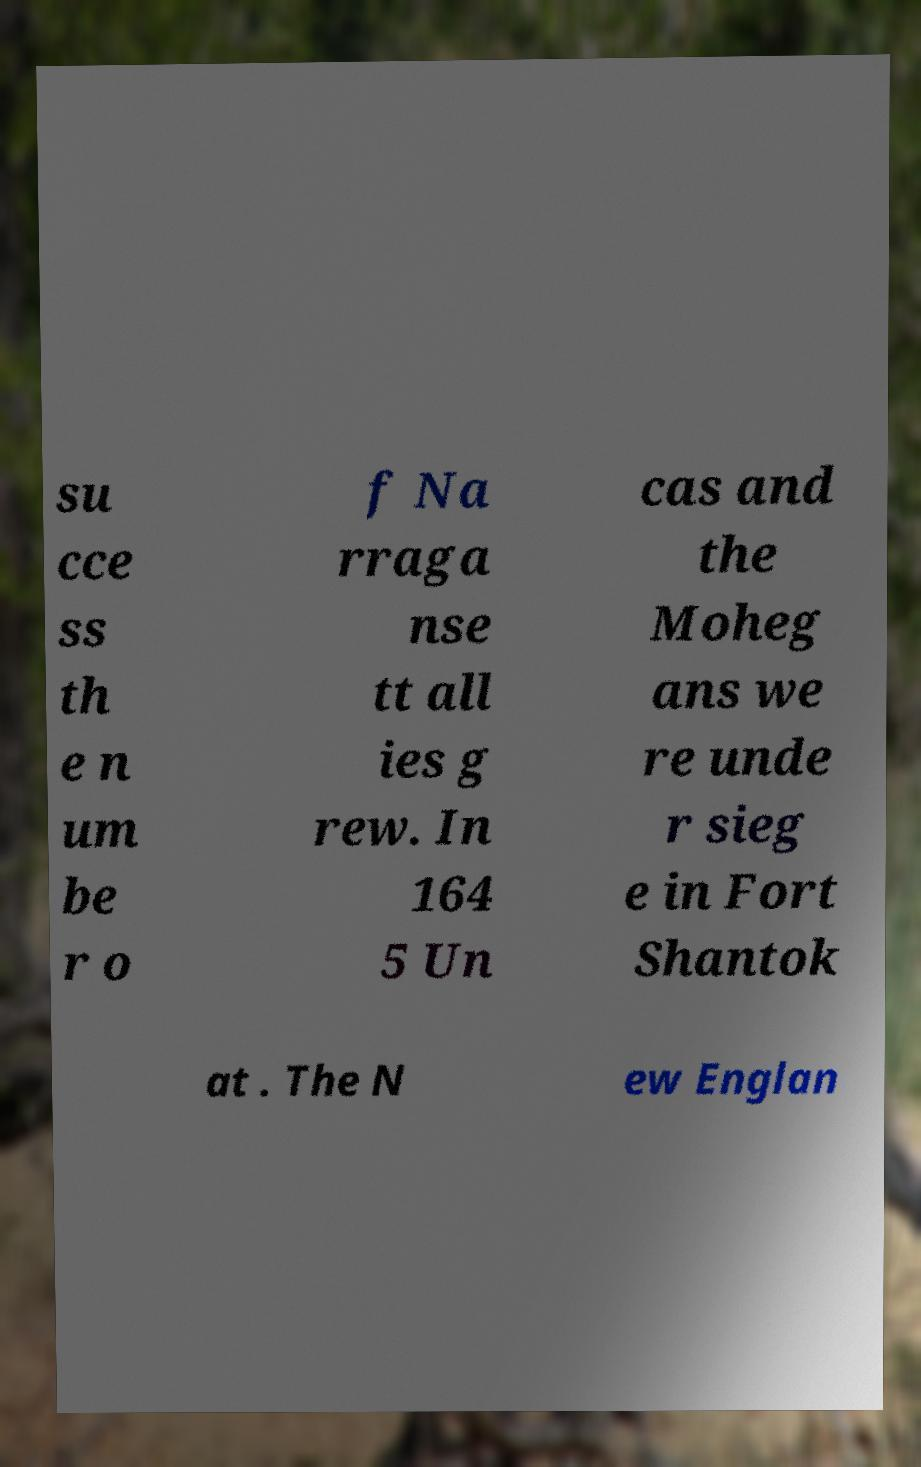Could you assist in decoding the text presented in this image and type it out clearly? su cce ss th e n um be r o f Na rraga nse tt all ies g rew. In 164 5 Un cas and the Moheg ans we re unde r sieg e in Fort Shantok at . The N ew Englan 